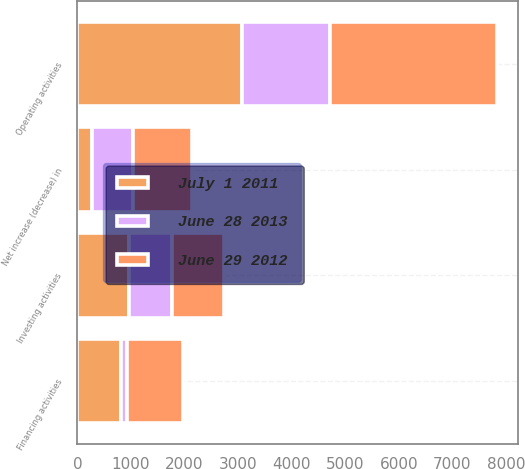Convert chart. <chart><loc_0><loc_0><loc_500><loc_500><stacked_bar_chart><ecel><fcel>Operating activities<fcel>Investing activities<fcel>Financing activities<fcel>Net increase (decrease) in<nl><fcel>June 29 2012<fcel>3119<fcel>970<fcel>1048<fcel>1101<nl><fcel>July 1 2011<fcel>3067<fcel>970<fcel>819<fcel>282<nl><fcel>June 28 2013<fcel>1655<fcel>793<fcel>106<fcel>756<nl></chart> 